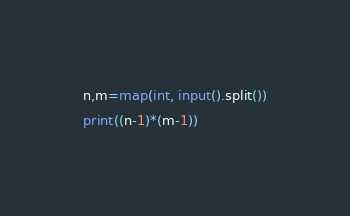Convert code to text. <code><loc_0><loc_0><loc_500><loc_500><_Python_>n,m=map(int, input().split())
print((n-1)*(m-1))</code> 